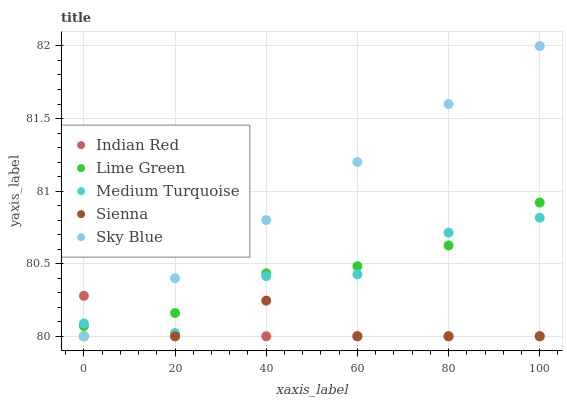Does Indian Red have the minimum area under the curve?
Answer yes or no. Yes. Does Sky Blue have the maximum area under the curve?
Answer yes or no. Yes. Does Lime Green have the minimum area under the curve?
Answer yes or no. No. Does Lime Green have the maximum area under the curve?
Answer yes or no. No. Is Sky Blue the smoothest?
Answer yes or no. Yes. Is Medium Turquoise the roughest?
Answer yes or no. Yes. Is Lime Green the smoothest?
Answer yes or no. No. Is Lime Green the roughest?
Answer yes or no. No. Does Sienna have the lowest value?
Answer yes or no. Yes. Does Lime Green have the lowest value?
Answer yes or no. No. Does Sky Blue have the highest value?
Answer yes or no. Yes. Does Lime Green have the highest value?
Answer yes or no. No. Is Sienna less than Medium Turquoise?
Answer yes or no. Yes. Is Medium Turquoise greater than Sienna?
Answer yes or no. Yes. Does Sky Blue intersect Lime Green?
Answer yes or no. Yes. Is Sky Blue less than Lime Green?
Answer yes or no. No. Is Sky Blue greater than Lime Green?
Answer yes or no. No. Does Sienna intersect Medium Turquoise?
Answer yes or no. No. 